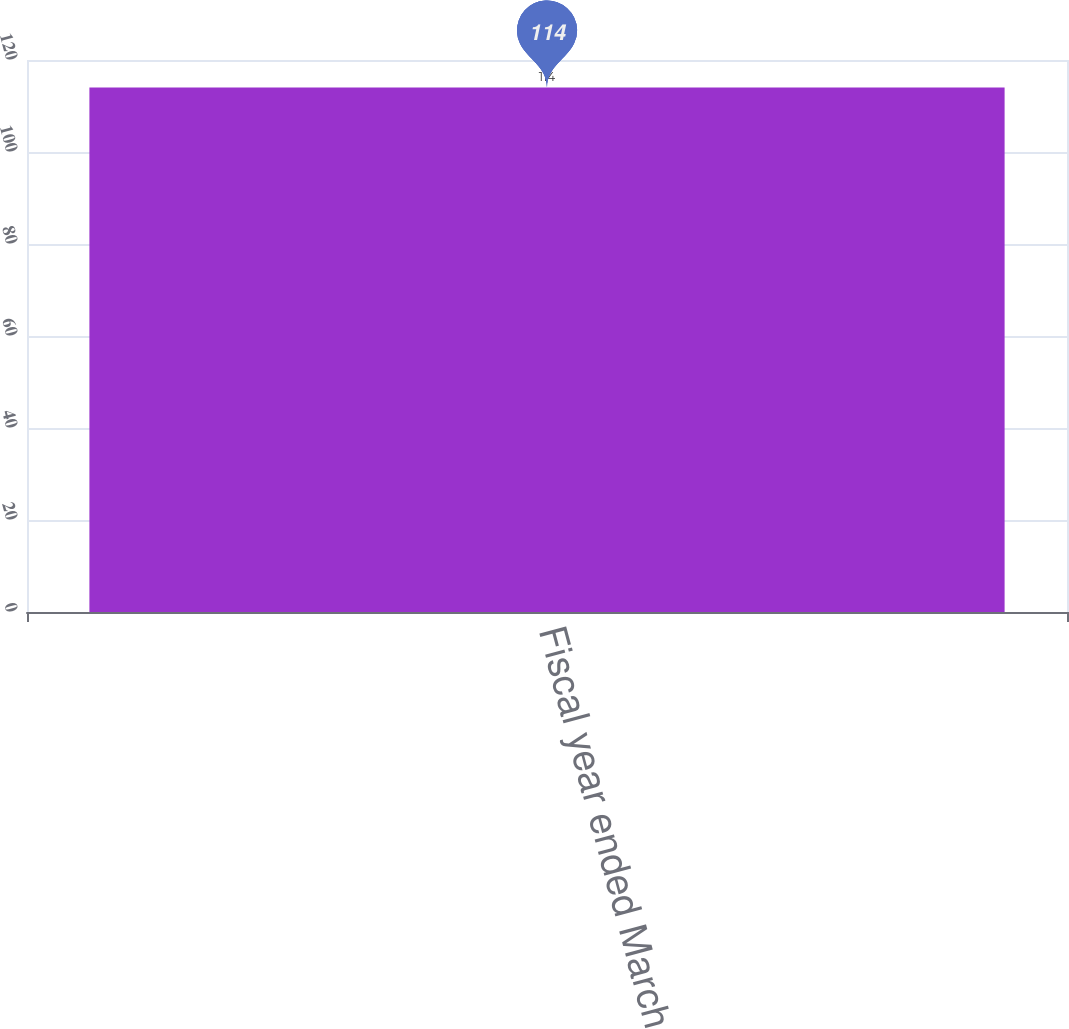<chart> <loc_0><loc_0><loc_500><loc_500><bar_chart><fcel>Fiscal year ended March 31<nl><fcel>114<nl></chart> 